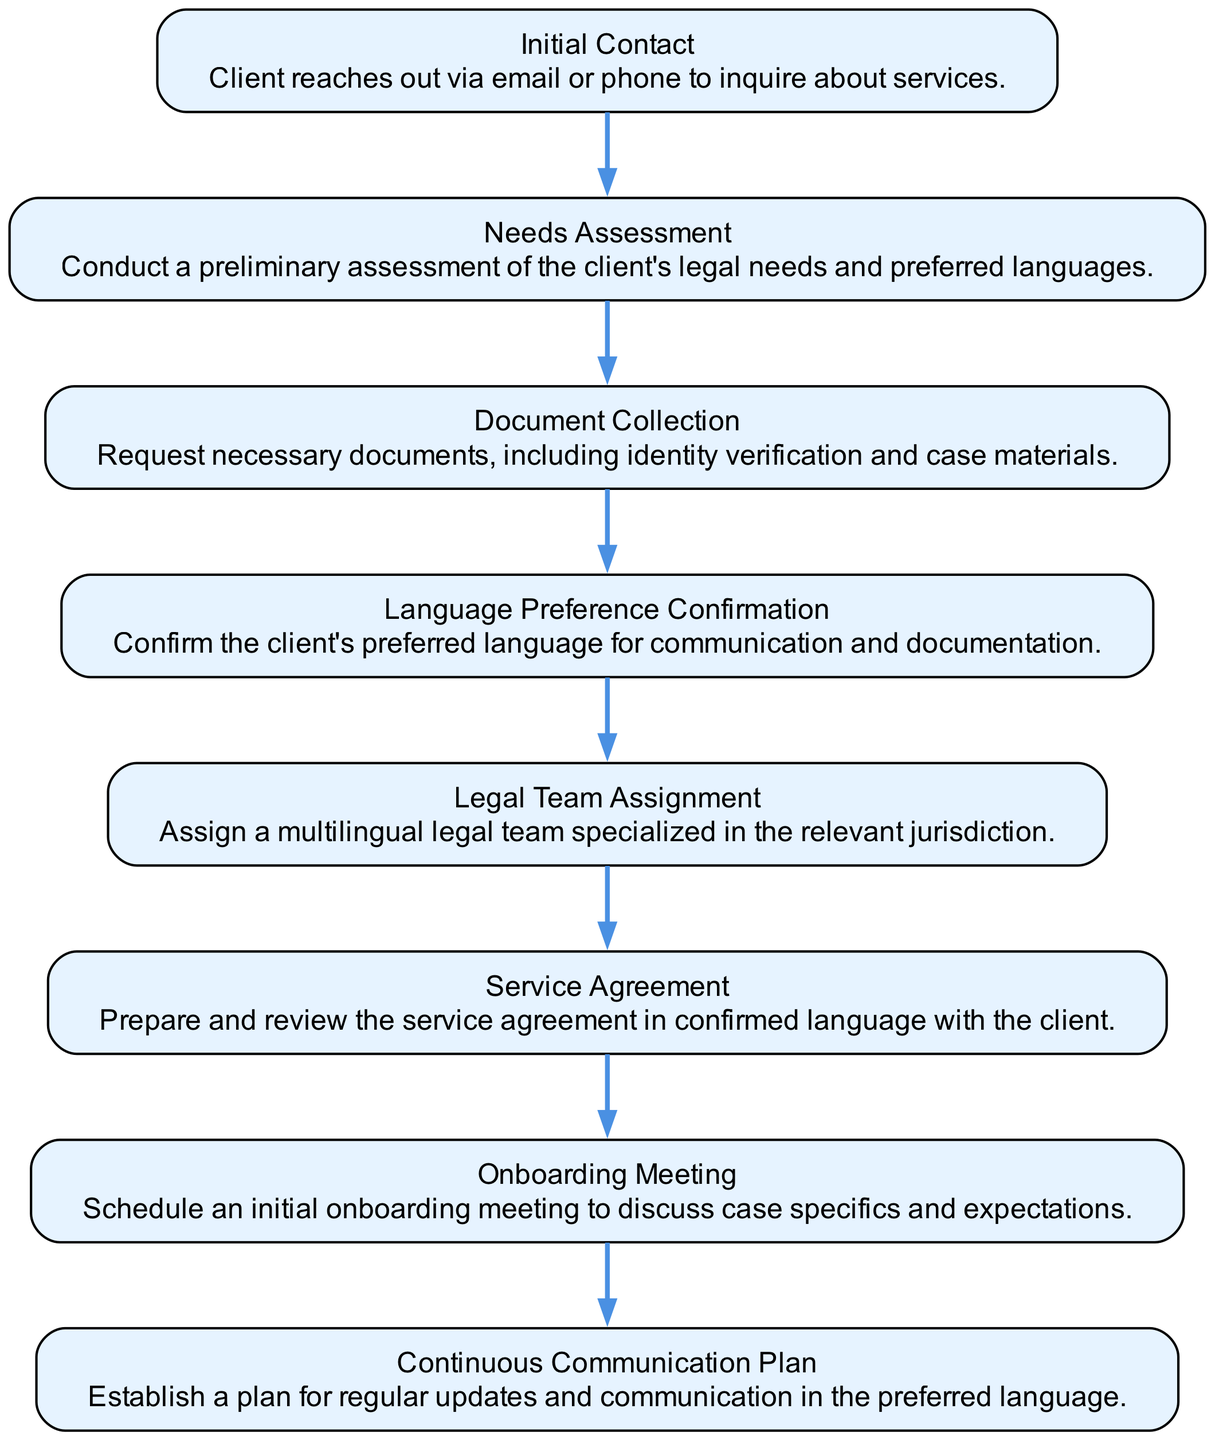What is the first step in the onboarding process? The diagram shows "Initial Contact" as the first step in the onboarding process. It states that the client reaches out via email or phone to inquire about services.
Answer: Initial Contact How many steps are in the client onboarding process? By counting the nodes in the diagram, there are a total of eight steps listed. Each box represents a step in the process.
Answer: Eight What comes after the Needs Assessment step? The diagram indicates that after "Needs Assessment," the next step is "Document Collection." This connects them in sequential order.
Answer: Document Collection What is the last step in the onboarding process? According to the diagram, the last step is "Continuous Communication Plan," which establishes a plan for ongoing communication.
Answer: Continuous Communication Plan What confirmed information is required before discussing the service agreement? The diagram highlights the necessity of "Language Preference Confirmation" as the step prior to the "Service Agreement." This information is essential for preparing the service agreement in the preferred language.
Answer: Language Preference Confirmation Which step includes scheduling a meeting? Referring to the diagram, the step titled "Onboarding Meeting" explicitly mentions the scheduling of an initial meeting to discuss case specifics.
Answer: Onboarding Meeting Name the step that involves preliminary assessment. In the diagram, "Needs Assessment" is the step where a preliminary assessment of the client's legal needs is conducted.
Answer: Needs Assessment What is the key requirement in the Document Collection step? The "Document Collection" step entails requesting necessary documents, including identity verification and case materials, as stated in the diagram.
Answer: Identity verification and case materials Which step follows after confirming the language preference? The diagram indicates that after "Language Preference Confirmation," the next step is "Legal Team Assignment," where a suitable team is assigned based on language needs and jurisdiction.
Answer: Legal Team Assignment 